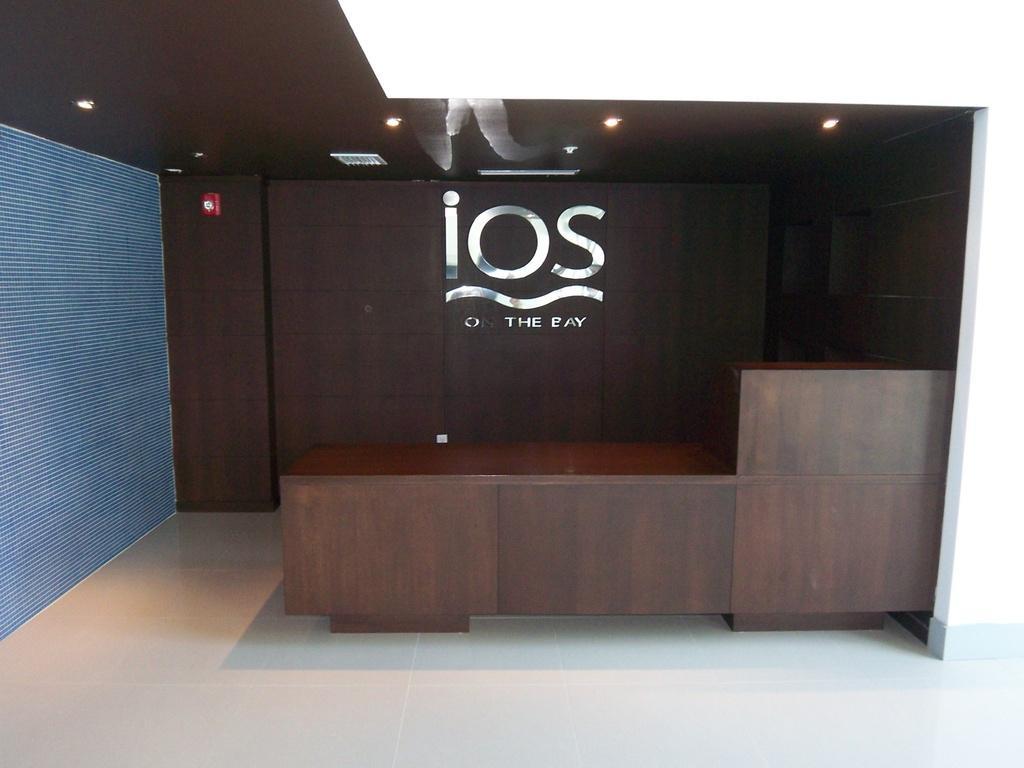Please provide a concise description of this image. In front of the image there is a wooden desk, behind the desk there is a name on the wooden wall and some object on the wall. At the top of the roof there are lamps. 